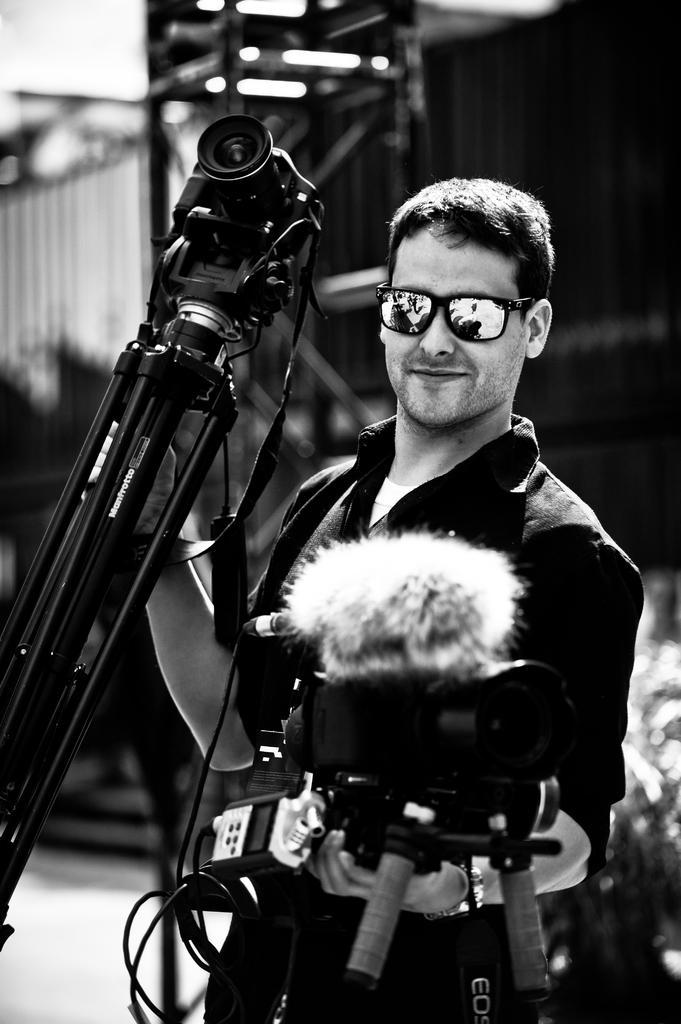Please provide a concise description of this image. This is a black and white image. Here I can see a man standing, holding a camera stand and a camera in the hands, smiling and giving pose for the picture. The background is blurred. 